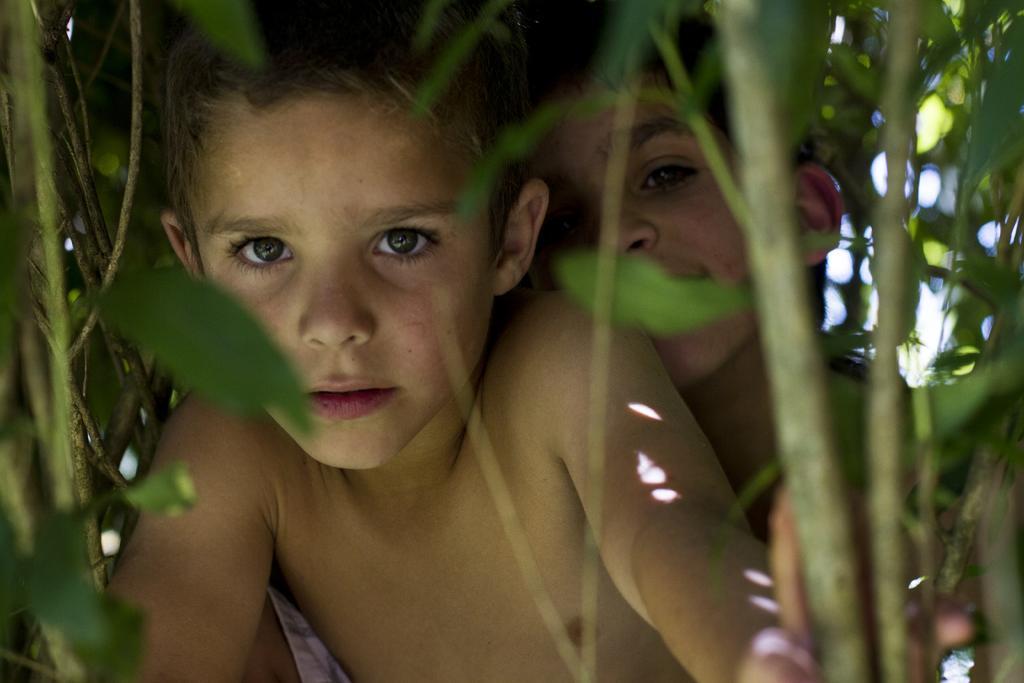Could you give a brief overview of what you see in this image? In this image, we can see some plants. There are kids in the middle of the image. 